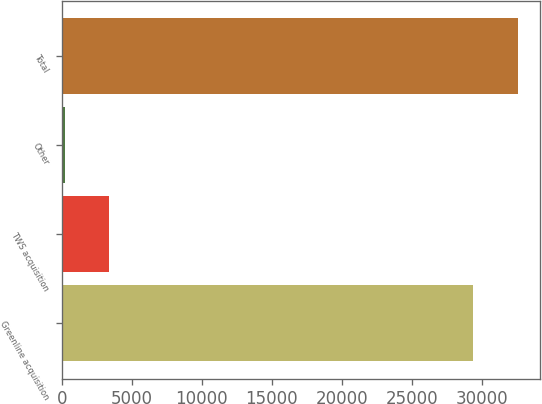<chart> <loc_0><loc_0><loc_500><loc_500><bar_chart><fcel>Greenline acquisition<fcel>TWS acquisition<fcel>Other<fcel>Total<nl><fcel>29405<fcel>3360.2<fcel>202<fcel>32563.2<nl></chart> 